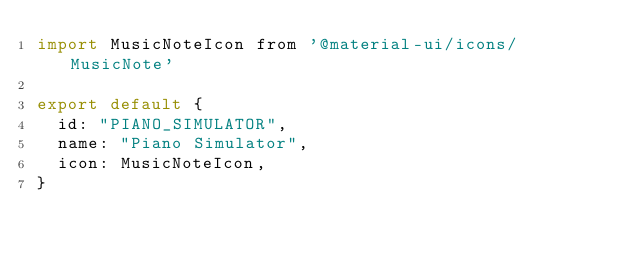<code> <loc_0><loc_0><loc_500><loc_500><_JavaScript_>import MusicNoteIcon from '@material-ui/icons/MusicNote'

export default {
  id: "PIANO_SIMULATOR",
  name: "Piano Simulator", 
  icon: MusicNoteIcon,
}
</code> 